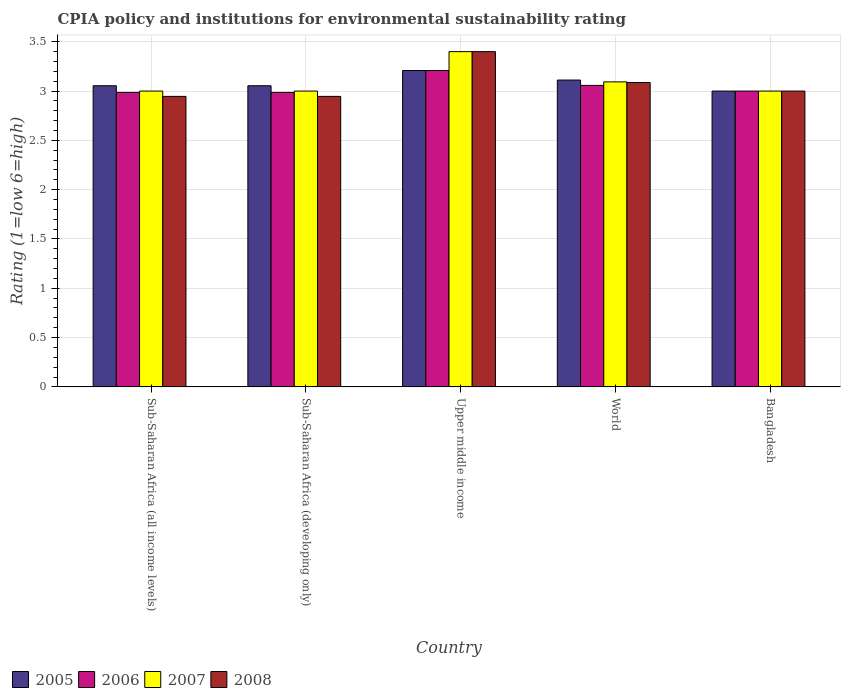How many groups of bars are there?
Make the answer very short. 5. How many bars are there on the 3rd tick from the left?
Your answer should be very brief. 4. What is the label of the 3rd group of bars from the left?
Your response must be concise. Upper middle income. Across all countries, what is the minimum CPIA rating in 2007?
Your response must be concise. 3. In which country was the CPIA rating in 2005 maximum?
Provide a short and direct response. Upper middle income. In which country was the CPIA rating in 2008 minimum?
Your answer should be compact. Sub-Saharan Africa (all income levels). What is the total CPIA rating in 2008 in the graph?
Your answer should be compact. 15.38. What is the difference between the CPIA rating in 2006 in Sub-Saharan Africa (all income levels) and that in World?
Your answer should be compact. -0.07. What is the difference between the CPIA rating in 2006 in Upper middle income and the CPIA rating in 2008 in Bangladesh?
Offer a terse response. 0.21. What is the average CPIA rating in 2005 per country?
Your answer should be very brief. 3.09. What is the difference between the CPIA rating of/in 2007 and CPIA rating of/in 2005 in Sub-Saharan Africa (all income levels)?
Offer a very short reply. -0.05. In how many countries, is the CPIA rating in 2007 greater than 0.30000000000000004?
Your response must be concise. 5. What is the ratio of the CPIA rating in 2008 in Sub-Saharan Africa (developing only) to that in Upper middle income?
Make the answer very short. 0.87. Is the CPIA rating in 2006 in Sub-Saharan Africa (all income levels) less than that in World?
Offer a very short reply. Yes. What is the difference between the highest and the second highest CPIA rating in 2007?
Your response must be concise. 0.09. What is the difference between the highest and the lowest CPIA rating in 2006?
Your response must be concise. 0.22. What does the 2nd bar from the left in Bangladesh represents?
Make the answer very short. 2006. Are all the bars in the graph horizontal?
Keep it short and to the point. No. How many countries are there in the graph?
Give a very brief answer. 5. Does the graph contain grids?
Ensure brevity in your answer.  Yes. How are the legend labels stacked?
Offer a terse response. Horizontal. What is the title of the graph?
Offer a very short reply. CPIA policy and institutions for environmental sustainability rating. What is the label or title of the X-axis?
Your answer should be very brief. Country. What is the label or title of the Y-axis?
Your answer should be compact. Rating (1=low 6=high). What is the Rating (1=low 6=high) in 2005 in Sub-Saharan Africa (all income levels)?
Your answer should be very brief. 3.05. What is the Rating (1=low 6=high) in 2006 in Sub-Saharan Africa (all income levels)?
Your answer should be compact. 2.99. What is the Rating (1=low 6=high) in 2008 in Sub-Saharan Africa (all income levels)?
Your answer should be very brief. 2.95. What is the Rating (1=low 6=high) in 2005 in Sub-Saharan Africa (developing only)?
Your response must be concise. 3.05. What is the Rating (1=low 6=high) of 2006 in Sub-Saharan Africa (developing only)?
Provide a short and direct response. 2.99. What is the Rating (1=low 6=high) of 2008 in Sub-Saharan Africa (developing only)?
Give a very brief answer. 2.95. What is the Rating (1=low 6=high) in 2005 in Upper middle income?
Make the answer very short. 3.21. What is the Rating (1=low 6=high) of 2006 in Upper middle income?
Provide a succinct answer. 3.21. What is the Rating (1=low 6=high) of 2008 in Upper middle income?
Provide a short and direct response. 3.4. What is the Rating (1=low 6=high) of 2005 in World?
Provide a short and direct response. 3.11. What is the Rating (1=low 6=high) in 2006 in World?
Your answer should be compact. 3.06. What is the Rating (1=low 6=high) of 2007 in World?
Your answer should be very brief. 3.09. What is the Rating (1=low 6=high) of 2008 in World?
Your answer should be compact. 3.09. What is the Rating (1=low 6=high) of 2005 in Bangladesh?
Keep it short and to the point. 3. What is the Rating (1=low 6=high) of 2008 in Bangladesh?
Your response must be concise. 3. Across all countries, what is the maximum Rating (1=low 6=high) in 2005?
Ensure brevity in your answer.  3.21. Across all countries, what is the maximum Rating (1=low 6=high) in 2006?
Provide a short and direct response. 3.21. Across all countries, what is the minimum Rating (1=low 6=high) in 2005?
Give a very brief answer. 3. Across all countries, what is the minimum Rating (1=low 6=high) of 2006?
Offer a very short reply. 2.99. Across all countries, what is the minimum Rating (1=low 6=high) in 2007?
Ensure brevity in your answer.  3. Across all countries, what is the minimum Rating (1=low 6=high) in 2008?
Give a very brief answer. 2.95. What is the total Rating (1=low 6=high) in 2005 in the graph?
Make the answer very short. 15.43. What is the total Rating (1=low 6=high) of 2006 in the graph?
Provide a succinct answer. 15.24. What is the total Rating (1=low 6=high) of 2007 in the graph?
Provide a short and direct response. 15.49. What is the total Rating (1=low 6=high) in 2008 in the graph?
Make the answer very short. 15.38. What is the difference between the Rating (1=low 6=high) in 2007 in Sub-Saharan Africa (all income levels) and that in Sub-Saharan Africa (developing only)?
Give a very brief answer. 0. What is the difference between the Rating (1=low 6=high) of 2008 in Sub-Saharan Africa (all income levels) and that in Sub-Saharan Africa (developing only)?
Provide a succinct answer. 0. What is the difference between the Rating (1=low 6=high) in 2005 in Sub-Saharan Africa (all income levels) and that in Upper middle income?
Give a very brief answer. -0.15. What is the difference between the Rating (1=low 6=high) of 2006 in Sub-Saharan Africa (all income levels) and that in Upper middle income?
Offer a terse response. -0.22. What is the difference between the Rating (1=low 6=high) in 2008 in Sub-Saharan Africa (all income levels) and that in Upper middle income?
Keep it short and to the point. -0.45. What is the difference between the Rating (1=low 6=high) in 2005 in Sub-Saharan Africa (all income levels) and that in World?
Your answer should be very brief. -0.06. What is the difference between the Rating (1=low 6=high) of 2006 in Sub-Saharan Africa (all income levels) and that in World?
Offer a terse response. -0.07. What is the difference between the Rating (1=low 6=high) of 2007 in Sub-Saharan Africa (all income levels) and that in World?
Make the answer very short. -0.09. What is the difference between the Rating (1=low 6=high) of 2008 in Sub-Saharan Africa (all income levels) and that in World?
Give a very brief answer. -0.14. What is the difference between the Rating (1=low 6=high) in 2005 in Sub-Saharan Africa (all income levels) and that in Bangladesh?
Provide a succinct answer. 0.05. What is the difference between the Rating (1=low 6=high) of 2006 in Sub-Saharan Africa (all income levels) and that in Bangladesh?
Make the answer very short. -0.01. What is the difference between the Rating (1=low 6=high) of 2008 in Sub-Saharan Africa (all income levels) and that in Bangladesh?
Give a very brief answer. -0.05. What is the difference between the Rating (1=low 6=high) of 2005 in Sub-Saharan Africa (developing only) and that in Upper middle income?
Ensure brevity in your answer.  -0.15. What is the difference between the Rating (1=low 6=high) of 2006 in Sub-Saharan Africa (developing only) and that in Upper middle income?
Give a very brief answer. -0.22. What is the difference between the Rating (1=low 6=high) of 2007 in Sub-Saharan Africa (developing only) and that in Upper middle income?
Offer a very short reply. -0.4. What is the difference between the Rating (1=low 6=high) of 2008 in Sub-Saharan Africa (developing only) and that in Upper middle income?
Your answer should be compact. -0.45. What is the difference between the Rating (1=low 6=high) of 2005 in Sub-Saharan Africa (developing only) and that in World?
Offer a very short reply. -0.06. What is the difference between the Rating (1=low 6=high) in 2006 in Sub-Saharan Africa (developing only) and that in World?
Your answer should be very brief. -0.07. What is the difference between the Rating (1=low 6=high) of 2007 in Sub-Saharan Africa (developing only) and that in World?
Your answer should be compact. -0.09. What is the difference between the Rating (1=low 6=high) of 2008 in Sub-Saharan Africa (developing only) and that in World?
Your response must be concise. -0.14. What is the difference between the Rating (1=low 6=high) in 2005 in Sub-Saharan Africa (developing only) and that in Bangladesh?
Make the answer very short. 0.05. What is the difference between the Rating (1=low 6=high) in 2006 in Sub-Saharan Africa (developing only) and that in Bangladesh?
Provide a succinct answer. -0.01. What is the difference between the Rating (1=low 6=high) in 2007 in Sub-Saharan Africa (developing only) and that in Bangladesh?
Your response must be concise. 0. What is the difference between the Rating (1=low 6=high) of 2008 in Sub-Saharan Africa (developing only) and that in Bangladesh?
Your answer should be compact. -0.05. What is the difference between the Rating (1=low 6=high) in 2005 in Upper middle income and that in World?
Give a very brief answer. 0.1. What is the difference between the Rating (1=low 6=high) in 2006 in Upper middle income and that in World?
Provide a succinct answer. 0.15. What is the difference between the Rating (1=low 6=high) in 2007 in Upper middle income and that in World?
Keep it short and to the point. 0.31. What is the difference between the Rating (1=low 6=high) of 2008 in Upper middle income and that in World?
Ensure brevity in your answer.  0.31. What is the difference between the Rating (1=low 6=high) in 2005 in Upper middle income and that in Bangladesh?
Offer a terse response. 0.21. What is the difference between the Rating (1=low 6=high) of 2006 in Upper middle income and that in Bangladesh?
Offer a very short reply. 0.21. What is the difference between the Rating (1=low 6=high) in 2007 in Upper middle income and that in Bangladesh?
Provide a succinct answer. 0.4. What is the difference between the Rating (1=low 6=high) in 2008 in Upper middle income and that in Bangladesh?
Give a very brief answer. 0.4. What is the difference between the Rating (1=low 6=high) of 2005 in World and that in Bangladesh?
Your answer should be very brief. 0.11. What is the difference between the Rating (1=low 6=high) of 2006 in World and that in Bangladesh?
Your answer should be very brief. 0.06. What is the difference between the Rating (1=low 6=high) in 2007 in World and that in Bangladesh?
Provide a short and direct response. 0.09. What is the difference between the Rating (1=low 6=high) of 2008 in World and that in Bangladesh?
Offer a very short reply. 0.09. What is the difference between the Rating (1=low 6=high) of 2005 in Sub-Saharan Africa (all income levels) and the Rating (1=low 6=high) of 2006 in Sub-Saharan Africa (developing only)?
Offer a terse response. 0.07. What is the difference between the Rating (1=low 6=high) in 2005 in Sub-Saharan Africa (all income levels) and the Rating (1=low 6=high) in 2007 in Sub-Saharan Africa (developing only)?
Make the answer very short. 0.05. What is the difference between the Rating (1=low 6=high) of 2005 in Sub-Saharan Africa (all income levels) and the Rating (1=low 6=high) of 2008 in Sub-Saharan Africa (developing only)?
Your answer should be compact. 0.11. What is the difference between the Rating (1=low 6=high) in 2006 in Sub-Saharan Africa (all income levels) and the Rating (1=low 6=high) in 2007 in Sub-Saharan Africa (developing only)?
Your answer should be very brief. -0.01. What is the difference between the Rating (1=low 6=high) in 2006 in Sub-Saharan Africa (all income levels) and the Rating (1=low 6=high) in 2008 in Sub-Saharan Africa (developing only)?
Keep it short and to the point. 0.04. What is the difference between the Rating (1=low 6=high) of 2007 in Sub-Saharan Africa (all income levels) and the Rating (1=low 6=high) of 2008 in Sub-Saharan Africa (developing only)?
Your answer should be very brief. 0.05. What is the difference between the Rating (1=low 6=high) in 2005 in Sub-Saharan Africa (all income levels) and the Rating (1=low 6=high) in 2006 in Upper middle income?
Offer a very short reply. -0.15. What is the difference between the Rating (1=low 6=high) in 2005 in Sub-Saharan Africa (all income levels) and the Rating (1=low 6=high) in 2007 in Upper middle income?
Offer a terse response. -0.35. What is the difference between the Rating (1=low 6=high) in 2005 in Sub-Saharan Africa (all income levels) and the Rating (1=low 6=high) in 2008 in Upper middle income?
Provide a short and direct response. -0.35. What is the difference between the Rating (1=low 6=high) of 2006 in Sub-Saharan Africa (all income levels) and the Rating (1=low 6=high) of 2007 in Upper middle income?
Make the answer very short. -0.41. What is the difference between the Rating (1=low 6=high) of 2006 in Sub-Saharan Africa (all income levels) and the Rating (1=low 6=high) of 2008 in Upper middle income?
Offer a very short reply. -0.41. What is the difference between the Rating (1=low 6=high) of 2007 in Sub-Saharan Africa (all income levels) and the Rating (1=low 6=high) of 2008 in Upper middle income?
Offer a very short reply. -0.4. What is the difference between the Rating (1=low 6=high) in 2005 in Sub-Saharan Africa (all income levels) and the Rating (1=low 6=high) in 2006 in World?
Make the answer very short. -0. What is the difference between the Rating (1=low 6=high) of 2005 in Sub-Saharan Africa (all income levels) and the Rating (1=low 6=high) of 2007 in World?
Give a very brief answer. -0.04. What is the difference between the Rating (1=low 6=high) of 2005 in Sub-Saharan Africa (all income levels) and the Rating (1=low 6=high) of 2008 in World?
Keep it short and to the point. -0.03. What is the difference between the Rating (1=low 6=high) in 2006 in Sub-Saharan Africa (all income levels) and the Rating (1=low 6=high) in 2007 in World?
Your response must be concise. -0.11. What is the difference between the Rating (1=low 6=high) of 2006 in Sub-Saharan Africa (all income levels) and the Rating (1=low 6=high) of 2008 in World?
Give a very brief answer. -0.1. What is the difference between the Rating (1=low 6=high) in 2007 in Sub-Saharan Africa (all income levels) and the Rating (1=low 6=high) in 2008 in World?
Your answer should be very brief. -0.09. What is the difference between the Rating (1=low 6=high) in 2005 in Sub-Saharan Africa (all income levels) and the Rating (1=low 6=high) in 2006 in Bangladesh?
Make the answer very short. 0.05. What is the difference between the Rating (1=low 6=high) in 2005 in Sub-Saharan Africa (all income levels) and the Rating (1=low 6=high) in 2007 in Bangladesh?
Offer a very short reply. 0.05. What is the difference between the Rating (1=low 6=high) of 2005 in Sub-Saharan Africa (all income levels) and the Rating (1=low 6=high) of 2008 in Bangladesh?
Provide a succinct answer. 0.05. What is the difference between the Rating (1=low 6=high) of 2006 in Sub-Saharan Africa (all income levels) and the Rating (1=low 6=high) of 2007 in Bangladesh?
Offer a very short reply. -0.01. What is the difference between the Rating (1=low 6=high) of 2006 in Sub-Saharan Africa (all income levels) and the Rating (1=low 6=high) of 2008 in Bangladesh?
Offer a terse response. -0.01. What is the difference between the Rating (1=low 6=high) in 2005 in Sub-Saharan Africa (developing only) and the Rating (1=low 6=high) in 2006 in Upper middle income?
Ensure brevity in your answer.  -0.15. What is the difference between the Rating (1=low 6=high) of 2005 in Sub-Saharan Africa (developing only) and the Rating (1=low 6=high) of 2007 in Upper middle income?
Offer a very short reply. -0.35. What is the difference between the Rating (1=low 6=high) in 2005 in Sub-Saharan Africa (developing only) and the Rating (1=low 6=high) in 2008 in Upper middle income?
Your answer should be very brief. -0.35. What is the difference between the Rating (1=low 6=high) in 2006 in Sub-Saharan Africa (developing only) and the Rating (1=low 6=high) in 2007 in Upper middle income?
Provide a succinct answer. -0.41. What is the difference between the Rating (1=low 6=high) in 2006 in Sub-Saharan Africa (developing only) and the Rating (1=low 6=high) in 2008 in Upper middle income?
Give a very brief answer. -0.41. What is the difference between the Rating (1=low 6=high) of 2005 in Sub-Saharan Africa (developing only) and the Rating (1=low 6=high) of 2006 in World?
Your answer should be very brief. -0. What is the difference between the Rating (1=low 6=high) in 2005 in Sub-Saharan Africa (developing only) and the Rating (1=low 6=high) in 2007 in World?
Your answer should be compact. -0.04. What is the difference between the Rating (1=low 6=high) of 2005 in Sub-Saharan Africa (developing only) and the Rating (1=low 6=high) of 2008 in World?
Your answer should be very brief. -0.03. What is the difference between the Rating (1=low 6=high) in 2006 in Sub-Saharan Africa (developing only) and the Rating (1=low 6=high) in 2007 in World?
Provide a short and direct response. -0.11. What is the difference between the Rating (1=low 6=high) in 2006 in Sub-Saharan Africa (developing only) and the Rating (1=low 6=high) in 2008 in World?
Provide a short and direct response. -0.1. What is the difference between the Rating (1=low 6=high) in 2007 in Sub-Saharan Africa (developing only) and the Rating (1=low 6=high) in 2008 in World?
Your answer should be compact. -0.09. What is the difference between the Rating (1=low 6=high) of 2005 in Sub-Saharan Africa (developing only) and the Rating (1=low 6=high) of 2006 in Bangladesh?
Give a very brief answer. 0.05. What is the difference between the Rating (1=low 6=high) of 2005 in Sub-Saharan Africa (developing only) and the Rating (1=low 6=high) of 2007 in Bangladesh?
Offer a terse response. 0.05. What is the difference between the Rating (1=low 6=high) in 2005 in Sub-Saharan Africa (developing only) and the Rating (1=low 6=high) in 2008 in Bangladesh?
Give a very brief answer. 0.05. What is the difference between the Rating (1=low 6=high) in 2006 in Sub-Saharan Africa (developing only) and the Rating (1=low 6=high) in 2007 in Bangladesh?
Ensure brevity in your answer.  -0.01. What is the difference between the Rating (1=low 6=high) of 2006 in Sub-Saharan Africa (developing only) and the Rating (1=low 6=high) of 2008 in Bangladesh?
Give a very brief answer. -0.01. What is the difference between the Rating (1=low 6=high) of 2007 in Sub-Saharan Africa (developing only) and the Rating (1=low 6=high) of 2008 in Bangladesh?
Offer a very short reply. 0. What is the difference between the Rating (1=low 6=high) of 2005 in Upper middle income and the Rating (1=low 6=high) of 2006 in World?
Keep it short and to the point. 0.15. What is the difference between the Rating (1=low 6=high) of 2005 in Upper middle income and the Rating (1=low 6=high) of 2007 in World?
Offer a terse response. 0.12. What is the difference between the Rating (1=low 6=high) of 2005 in Upper middle income and the Rating (1=low 6=high) of 2008 in World?
Make the answer very short. 0.12. What is the difference between the Rating (1=low 6=high) in 2006 in Upper middle income and the Rating (1=low 6=high) in 2007 in World?
Provide a short and direct response. 0.12. What is the difference between the Rating (1=low 6=high) in 2006 in Upper middle income and the Rating (1=low 6=high) in 2008 in World?
Your response must be concise. 0.12. What is the difference between the Rating (1=low 6=high) in 2007 in Upper middle income and the Rating (1=low 6=high) in 2008 in World?
Your answer should be compact. 0.31. What is the difference between the Rating (1=low 6=high) in 2005 in Upper middle income and the Rating (1=low 6=high) in 2006 in Bangladesh?
Give a very brief answer. 0.21. What is the difference between the Rating (1=low 6=high) of 2005 in Upper middle income and the Rating (1=low 6=high) of 2007 in Bangladesh?
Offer a very short reply. 0.21. What is the difference between the Rating (1=low 6=high) of 2005 in Upper middle income and the Rating (1=low 6=high) of 2008 in Bangladesh?
Your response must be concise. 0.21. What is the difference between the Rating (1=low 6=high) of 2006 in Upper middle income and the Rating (1=low 6=high) of 2007 in Bangladesh?
Give a very brief answer. 0.21. What is the difference between the Rating (1=low 6=high) in 2006 in Upper middle income and the Rating (1=low 6=high) in 2008 in Bangladesh?
Your answer should be very brief. 0.21. What is the difference between the Rating (1=low 6=high) of 2007 in Upper middle income and the Rating (1=low 6=high) of 2008 in Bangladesh?
Provide a short and direct response. 0.4. What is the difference between the Rating (1=low 6=high) of 2005 in World and the Rating (1=low 6=high) of 2006 in Bangladesh?
Provide a short and direct response. 0.11. What is the difference between the Rating (1=low 6=high) of 2005 in World and the Rating (1=low 6=high) of 2007 in Bangladesh?
Your answer should be very brief. 0.11. What is the difference between the Rating (1=low 6=high) in 2005 in World and the Rating (1=low 6=high) in 2008 in Bangladesh?
Offer a terse response. 0.11. What is the difference between the Rating (1=low 6=high) of 2006 in World and the Rating (1=low 6=high) of 2007 in Bangladesh?
Your answer should be compact. 0.06. What is the difference between the Rating (1=low 6=high) in 2006 in World and the Rating (1=low 6=high) in 2008 in Bangladesh?
Make the answer very short. 0.06. What is the difference between the Rating (1=low 6=high) in 2007 in World and the Rating (1=low 6=high) in 2008 in Bangladesh?
Offer a terse response. 0.09. What is the average Rating (1=low 6=high) of 2005 per country?
Your answer should be very brief. 3.09. What is the average Rating (1=low 6=high) of 2006 per country?
Offer a very short reply. 3.05. What is the average Rating (1=low 6=high) in 2007 per country?
Make the answer very short. 3.1. What is the average Rating (1=low 6=high) of 2008 per country?
Your response must be concise. 3.08. What is the difference between the Rating (1=low 6=high) of 2005 and Rating (1=low 6=high) of 2006 in Sub-Saharan Africa (all income levels)?
Offer a very short reply. 0.07. What is the difference between the Rating (1=low 6=high) in 2005 and Rating (1=low 6=high) in 2007 in Sub-Saharan Africa (all income levels)?
Ensure brevity in your answer.  0.05. What is the difference between the Rating (1=low 6=high) in 2005 and Rating (1=low 6=high) in 2008 in Sub-Saharan Africa (all income levels)?
Your response must be concise. 0.11. What is the difference between the Rating (1=low 6=high) of 2006 and Rating (1=low 6=high) of 2007 in Sub-Saharan Africa (all income levels)?
Provide a succinct answer. -0.01. What is the difference between the Rating (1=low 6=high) of 2006 and Rating (1=low 6=high) of 2008 in Sub-Saharan Africa (all income levels)?
Ensure brevity in your answer.  0.04. What is the difference between the Rating (1=low 6=high) in 2007 and Rating (1=low 6=high) in 2008 in Sub-Saharan Africa (all income levels)?
Give a very brief answer. 0.05. What is the difference between the Rating (1=low 6=high) of 2005 and Rating (1=low 6=high) of 2006 in Sub-Saharan Africa (developing only)?
Your answer should be very brief. 0.07. What is the difference between the Rating (1=low 6=high) of 2005 and Rating (1=low 6=high) of 2007 in Sub-Saharan Africa (developing only)?
Keep it short and to the point. 0.05. What is the difference between the Rating (1=low 6=high) of 2005 and Rating (1=low 6=high) of 2008 in Sub-Saharan Africa (developing only)?
Ensure brevity in your answer.  0.11. What is the difference between the Rating (1=low 6=high) of 2006 and Rating (1=low 6=high) of 2007 in Sub-Saharan Africa (developing only)?
Keep it short and to the point. -0.01. What is the difference between the Rating (1=low 6=high) of 2006 and Rating (1=low 6=high) of 2008 in Sub-Saharan Africa (developing only)?
Give a very brief answer. 0.04. What is the difference between the Rating (1=low 6=high) of 2007 and Rating (1=low 6=high) of 2008 in Sub-Saharan Africa (developing only)?
Your response must be concise. 0.05. What is the difference between the Rating (1=low 6=high) in 2005 and Rating (1=low 6=high) in 2007 in Upper middle income?
Ensure brevity in your answer.  -0.19. What is the difference between the Rating (1=low 6=high) in 2005 and Rating (1=low 6=high) in 2008 in Upper middle income?
Your answer should be very brief. -0.19. What is the difference between the Rating (1=low 6=high) of 2006 and Rating (1=low 6=high) of 2007 in Upper middle income?
Give a very brief answer. -0.19. What is the difference between the Rating (1=low 6=high) in 2006 and Rating (1=low 6=high) in 2008 in Upper middle income?
Your response must be concise. -0.19. What is the difference between the Rating (1=low 6=high) in 2005 and Rating (1=low 6=high) in 2006 in World?
Your answer should be compact. 0.05. What is the difference between the Rating (1=low 6=high) in 2005 and Rating (1=low 6=high) in 2007 in World?
Offer a very short reply. 0.02. What is the difference between the Rating (1=low 6=high) of 2005 and Rating (1=low 6=high) of 2008 in World?
Your answer should be very brief. 0.03. What is the difference between the Rating (1=low 6=high) of 2006 and Rating (1=low 6=high) of 2007 in World?
Provide a short and direct response. -0.04. What is the difference between the Rating (1=low 6=high) of 2006 and Rating (1=low 6=high) of 2008 in World?
Keep it short and to the point. -0.03. What is the difference between the Rating (1=low 6=high) in 2007 and Rating (1=low 6=high) in 2008 in World?
Make the answer very short. 0.01. What is the difference between the Rating (1=low 6=high) of 2005 and Rating (1=low 6=high) of 2006 in Bangladesh?
Ensure brevity in your answer.  0. What is the difference between the Rating (1=low 6=high) in 2005 and Rating (1=low 6=high) in 2008 in Bangladesh?
Your response must be concise. 0. What is the difference between the Rating (1=low 6=high) in 2006 and Rating (1=low 6=high) in 2007 in Bangladesh?
Your answer should be compact. 0. What is the difference between the Rating (1=low 6=high) in 2006 and Rating (1=low 6=high) in 2008 in Bangladesh?
Offer a terse response. 0. What is the ratio of the Rating (1=low 6=high) in 2005 in Sub-Saharan Africa (all income levels) to that in Sub-Saharan Africa (developing only)?
Offer a terse response. 1. What is the ratio of the Rating (1=low 6=high) of 2006 in Sub-Saharan Africa (all income levels) to that in Sub-Saharan Africa (developing only)?
Ensure brevity in your answer.  1. What is the ratio of the Rating (1=low 6=high) of 2007 in Sub-Saharan Africa (all income levels) to that in Sub-Saharan Africa (developing only)?
Make the answer very short. 1. What is the ratio of the Rating (1=low 6=high) of 2005 in Sub-Saharan Africa (all income levels) to that in Upper middle income?
Make the answer very short. 0.95. What is the ratio of the Rating (1=low 6=high) in 2006 in Sub-Saharan Africa (all income levels) to that in Upper middle income?
Offer a terse response. 0.93. What is the ratio of the Rating (1=low 6=high) of 2007 in Sub-Saharan Africa (all income levels) to that in Upper middle income?
Your answer should be compact. 0.88. What is the ratio of the Rating (1=low 6=high) of 2008 in Sub-Saharan Africa (all income levels) to that in Upper middle income?
Give a very brief answer. 0.87. What is the ratio of the Rating (1=low 6=high) in 2005 in Sub-Saharan Africa (all income levels) to that in World?
Provide a short and direct response. 0.98. What is the ratio of the Rating (1=low 6=high) in 2006 in Sub-Saharan Africa (all income levels) to that in World?
Make the answer very short. 0.98. What is the ratio of the Rating (1=low 6=high) in 2007 in Sub-Saharan Africa (all income levels) to that in World?
Provide a short and direct response. 0.97. What is the ratio of the Rating (1=low 6=high) in 2008 in Sub-Saharan Africa (all income levels) to that in World?
Your answer should be compact. 0.95. What is the ratio of the Rating (1=low 6=high) in 2005 in Sub-Saharan Africa (all income levels) to that in Bangladesh?
Offer a terse response. 1.02. What is the ratio of the Rating (1=low 6=high) of 2007 in Sub-Saharan Africa (all income levels) to that in Bangladesh?
Make the answer very short. 1. What is the ratio of the Rating (1=low 6=high) of 2005 in Sub-Saharan Africa (developing only) to that in Upper middle income?
Provide a short and direct response. 0.95. What is the ratio of the Rating (1=low 6=high) of 2006 in Sub-Saharan Africa (developing only) to that in Upper middle income?
Keep it short and to the point. 0.93. What is the ratio of the Rating (1=low 6=high) in 2007 in Sub-Saharan Africa (developing only) to that in Upper middle income?
Make the answer very short. 0.88. What is the ratio of the Rating (1=low 6=high) in 2008 in Sub-Saharan Africa (developing only) to that in Upper middle income?
Offer a very short reply. 0.87. What is the ratio of the Rating (1=low 6=high) of 2005 in Sub-Saharan Africa (developing only) to that in World?
Keep it short and to the point. 0.98. What is the ratio of the Rating (1=low 6=high) of 2006 in Sub-Saharan Africa (developing only) to that in World?
Give a very brief answer. 0.98. What is the ratio of the Rating (1=low 6=high) of 2007 in Sub-Saharan Africa (developing only) to that in World?
Your answer should be compact. 0.97. What is the ratio of the Rating (1=low 6=high) in 2008 in Sub-Saharan Africa (developing only) to that in World?
Provide a succinct answer. 0.95. What is the ratio of the Rating (1=low 6=high) in 2005 in Sub-Saharan Africa (developing only) to that in Bangladesh?
Ensure brevity in your answer.  1.02. What is the ratio of the Rating (1=low 6=high) in 2006 in Sub-Saharan Africa (developing only) to that in Bangladesh?
Keep it short and to the point. 1. What is the ratio of the Rating (1=low 6=high) of 2007 in Sub-Saharan Africa (developing only) to that in Bangladesh?
Make the answer very short. 1. What is the ratio of the Rating (1=low 6=high) in 2005 in Upper middle income to that in World?
Offer a very short reply. 1.03. What is the ratio of the Rating (1=low 6=high) of 2006 in Upper middle income to that in World?
Provide a short and direct response. 1.05. What is the ratio of the Rating (1=low 6=high) of 2007 in Upper middle income to that in World?
Your answer should be very brief. 1.1. What is the ratio of the Rating (1=low 6=high) of 2008 in Upper middle income to that in World?
Keep it short and to the point. 1.1. What is the ratio of the Rating (1=low 6=high) in 2005 in Upper middle income to that in Bangladesh?
Give a very brief answer. 1.07. What is the ratio of the Rating (1=low 6=high) of 2006 in Upper middle income to that in Bangladesh?
Your answer should be very brief. 1.07. What is the ratio of the Rating (1=low 6=high) of 2007 in Upper middle income to that in Bangladesh?
Your answer should be very brief. 1.13. What is the ratio of the Rating (1=low 6=high) of 2008 in Upper middle income to that in Bangladesh?
Ensure brevity in your answer.  1.13. What is the ratio of the Rating (1=low 6=high) in 2005 in World to that in Bangladesh?
Provide a succinct answer. 1.04. What is the ratio of the Rating (1=low 6=high) of 2006 in World to that in Bangladesh?
Your answer should be compact. 1.02. What is the ratio of the Rating (1=low 6=high) of 2007 in World to that in Bangladesh?
Your response must be concise. 1.03. What is the ratio of the Rating (1=low 6=high) of 2008 in World to that in Bangladesh?
Your answer should be very brief. 1.03. What is the difference between the highest and the second highest Rating (1=low 6=high) in 2005?
Ensure brevity in your answer.  0.1. What is the difference between the highest and the second highest Rating (1=low 6=high) in 2006?
Offer a very short reply. 0.15. What is the difference between the highest and the second highest Rating (1=low 6=high) in 2007?
Your answer should be compact. 0.31. What is the difference between the highest and the second highest Rating (1=low 6=high) in 2008?
Your answer should be very brief. 0.31. What is the difference between the highest and the lowest Rating (1=low 6=high) of 2005?
Your answer should be very brief. 0.21. What is the difference between the highest and the lowest Rating (1=low 6=high) in 2006?
Offer a terse response. 0.22. What is the difference between the highest and the lowest Rating (1=low 6=high) of 2008?
Provide a succinct answer. 0.45. 